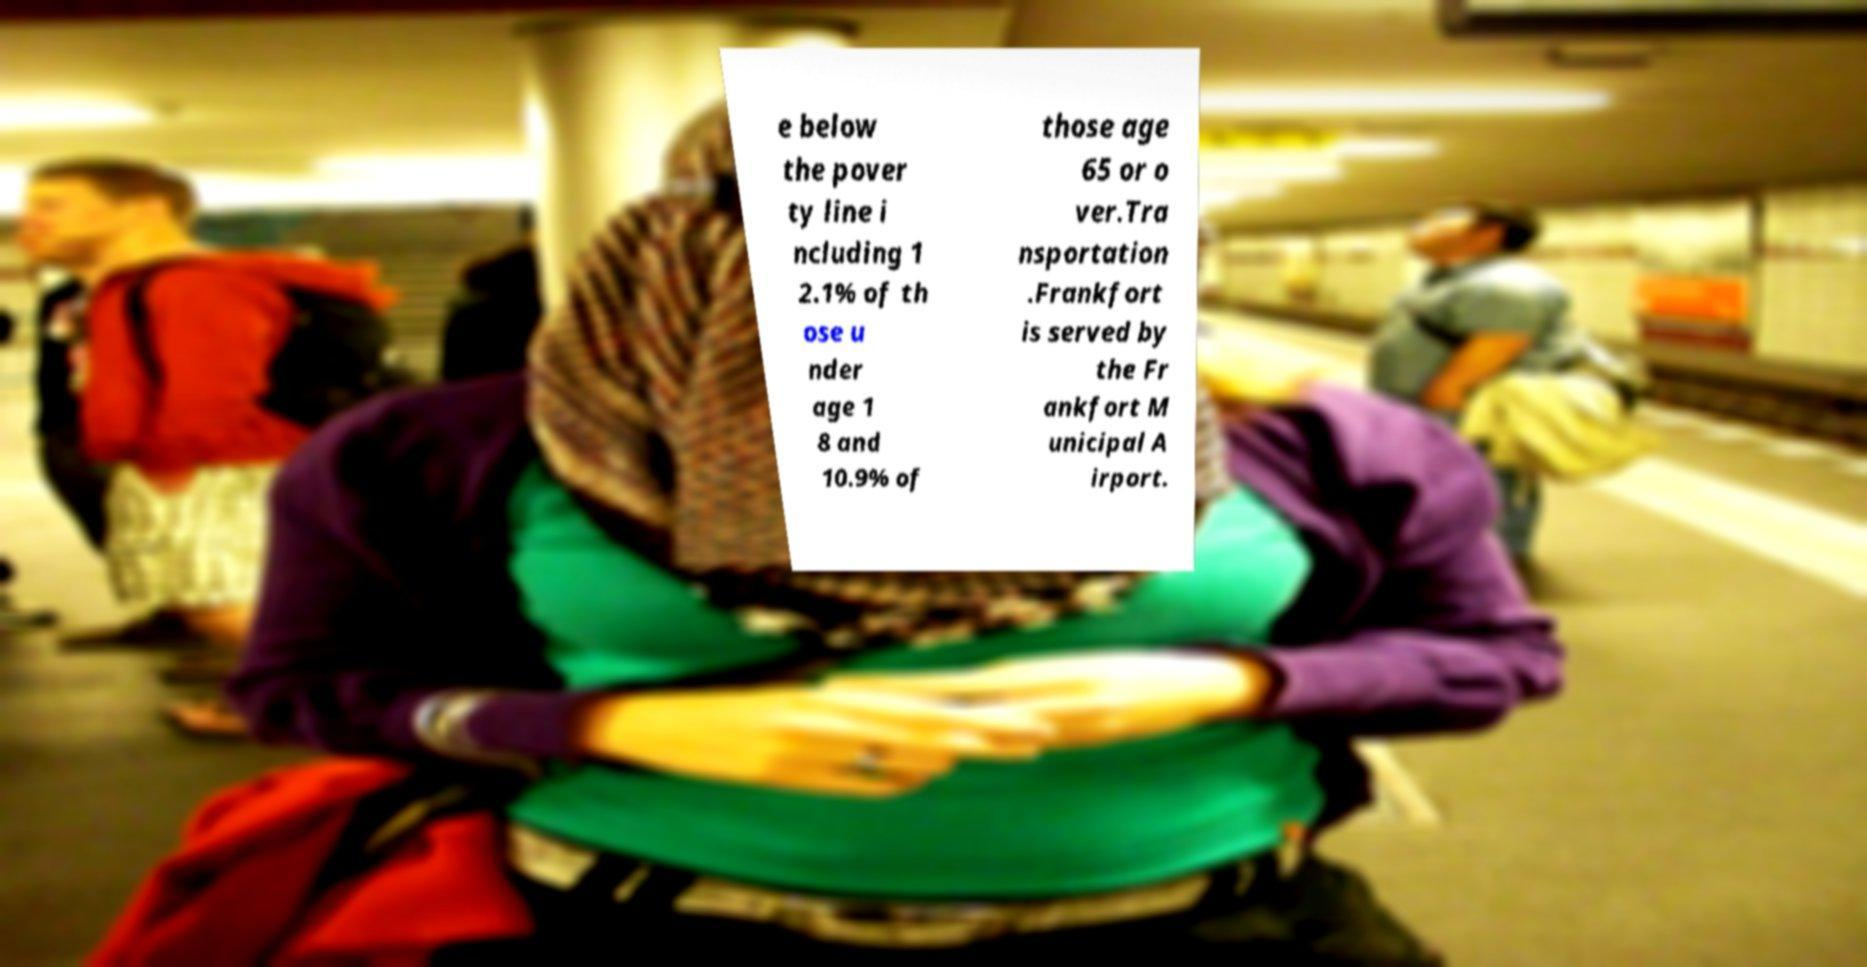There's text embedded in this image that I need extracted. Can you transcribe it verbatim? e below the pover ty line i ncluding 1 2.1% of th ose u nder age 1 8 and 10.9% of those age 65 or o ver.Tra nsportation .Frankfort is served by the Fr ankfort M unicipal A irport. 